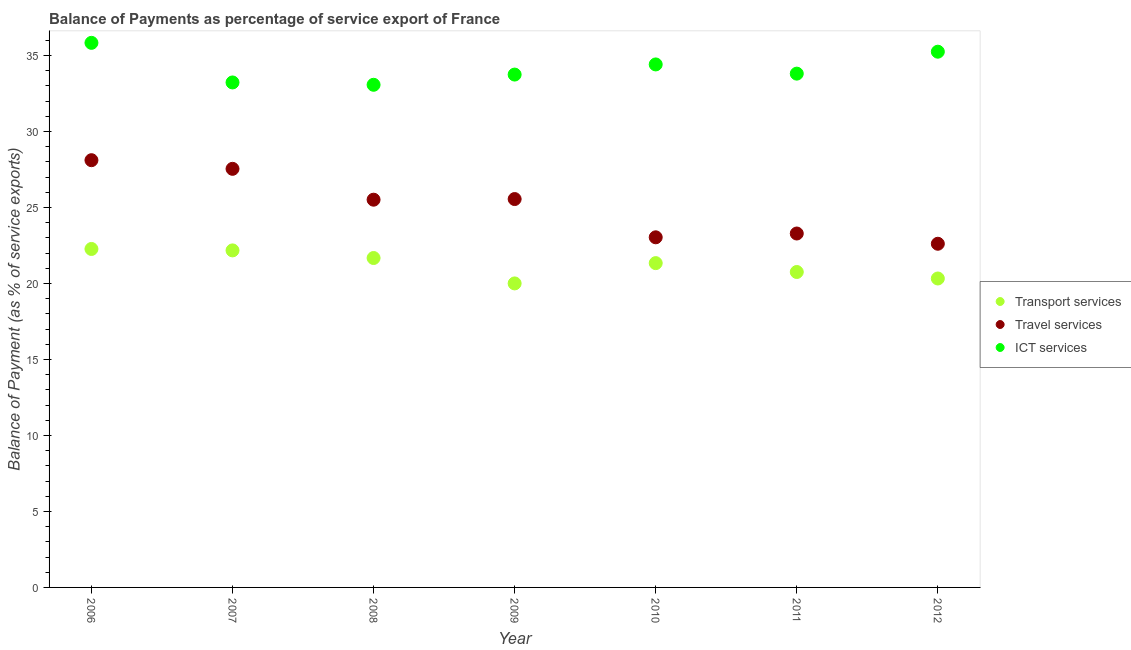How many different coloured dotlines are there?
Ensure brevity in your answer.  3. Is the number of dotlines equal to the number of legend labels?
Give a very brief answer. Yes. What is the balance of payment of transport services in 2012?
Your answer should be compact. 20.33. Across all years, what is the maximum balance of payment of transport services?
Make the answer very short. 22.27. Across all years, what is the minimum balance of payment of ict services?
Your answer should be very brief. 33.07. In which year was the balance of payment of travel services minimum?
Ensure brevity in your answer.  2012. What is the total balance of payment of travel services in the graph?
Keep it short and to the point. 175.66. What is the difference between the balance of payment of transport services in 2006 and that in 2007?
Your response must be concise. 0.09. What is the difference between the balance of payment of ict services in 2011 and the balance of payment of travel services in 2009?
Provide a succinct answer. 8.25. What is the average balance of payment of ict services per year?
Give a very brief answer. 34.19. In the year 2012, what is the difference between the balance of payment of travel services and balance of payment of transport services?
Your response must be concise. 2.29. In how many years, is the balance of payment of transport services greater than 1 %?
Ensure brevity in your answer.  7. What is the ratio of the balance of payment of ict services in 2008 to that in 2009?
Your response must be concise. 0.98. Is the difference between the balance of payment of travel services in 2009 and 2012 greater than the difference between the balance of payment of transport services in 2009 and 2012?
Provide a succinct answer. Yes. What is the difference between the highest and the second highest balance of payment of ict services?
Give a very brief answer. 0.58. What is the difference between the highest and the lowest balance of payment of travel services?
Your response must be concise. 5.5. In how many years, is the balance of payment of travel services greater than the average balance of payment of travel services taken over all years?
Your response must be concise. 4. Is the sum of the balance of payment of transport services in 2006 and 2009 greater than the maximum balance of payment of travel services across all years?
Provide a short and direct response. Yes. Is it the case that in every year, the sum of the balance of payment of transport services and balance of payment of travel services is greater than the balance of payment of ict services?
Offer a very short reply. Yes. Is the balance of payment of ict services strictly greater than the balance of payment of travel services over the years?
Your response must be concise. Yes. Is the balance of payment of travel services strictly less than the balance of payment of ict services over the years?
Ensure brevity in your answer.  Yes. How many years are there in the graph?
Offer a very short reply. 7. Are the values on the major ticks of Y-axis written in scientific E-notation?
Offer a terse response. No. Does the graph contain any zero values?
Provide a succinct answer. No. Where does the legend appear in the graph?
Offer a very short reply. Center right. What is the title of the graph?
Make the answer very short. Balance of Payments as percentage of service export of France. Does "Non-communicable diseases" appear as one of the legend labels in the graph?
Your answer should be compact. No. What is the label or title of the Y-axis?
Provide a short and direct response. Balance of Payment (as % of service exports). What is the Balance of Payment (as % of service exports) in Transport services in 2006?
Ensure brevity in your answer.  22.27. What is the Balance of Payment (as % of service exports) of Travel services in 2006?
Provide a succinct answer. 28.11. What is the Balance of Payment (as % of service exports) in ICT services in 2006?
Ensure brevity in your answer.  35.83. What is the Balance of Payment (as % of service exports) of Transport services in 2007?
Provide a succinct answer. 22.18. What is the Balance of Payment (as % of service exports) of Travel services in 2007?
Give a very brief answer. 27.54. What is the Balance of Payment (as % of service exports) of ICT services in 2007?
Ensure brevity in your answer.  33.23. What is the Balance of Payment (as % of service exports) in Transport services in 2008?
Provide a short and direct response. 21.67. What is the Balance of Payment (as % of service exports) of Travel services in 2008?
Offer a terse response. 25.51. What is the Balance of Payment (as % of service exports) in ICT services in 2008?
Your response must be concise. 33.07. What is the Balance of Payment (as % of service exports) in Transport services in 2009?
Give a very brief answer. 20. What is the Balance of Payment (as % of service exports) of Travel services in 2009?
Give a very brief answer. 25.55. What is the Balance of Payment (as % of service exports) in ICT services in 2009?
Your answer should be compact. 33.75. What is the Balance of Payment (as % of service exports) of Transport services in 2010?
Provide a short and direct response. 21.34. What is the Balance of Payment (as % of service exports) of Travel services in 2010?
Give a very brief answer. 23.04. What is the Balance of Payment (as % of service exports) of ICT services in 2010?
Provide a succinct answer. 34.41. What is the Balance of Payment (as % of service exports) in Transport services in 2011?
Provide a short and direct response. 20.75. What is the Balance of Payment (as % of service exports) of Travel services in 2011?
Your answer should be compact. 23.29. What is the Balance of Payment (as % of service exports) of ICT services in 2011?
Offer a very short reply. 33.81. What is the Balance of Payment (as % of service exports) of Transport services in 2012?
Offer a terse response. 20.33. What is the Balance of Payment (as % of service exports) of Travel services in 2012?
Your answer should be very brief. 22.61. What is the Balance of Payment (as % of service exports) in ICT services in 2012?
Ensure brevity in your answer.  35.25. Across all years, what is the maximum Balance of Payment (as % of service exports) in Transport services?
Your answer should be compact. 22.27. Across all years, what is the maximum Balance of Payment (as % of service exports) of Travel services?
Make the answer very short. 28.11. Across all years, what is the maximum Balance of Payment (as % of service exports) of ICT services?
Make the answer very short. 35.83. Across all years, what is the minimum Balance of Payment (as % of service exports) of Transport services?
Make the answer very short. 20. Across all years, what is the minimum Balance of Payment (as % of service exports) of Travel services?
Give a very brief answer. 22.61. Across all years, what is the minimum Balance of Payment (as % of service exports) of ICT services?
Provide a short and direct response. 33.07. What is the total Balance of Payment (as % of service exports) in Transport services in the graph?
Keep it short and to the point. 148.55. What is the total Balance of Payment (as % of service exports) of Travel services in the graph?
Offer a very short reply. 175.66. What is the total Balance of Payment (as % of service exports) in ICT services in the graph?
Offer a very short reply. 239.35. What is the difference between the Balance of Payment (as % of service exports) of Transport services in 2006 and that in 2007?
Offer a very short reply. 0.09. What is the difference between the Balance of Payment (as % of service exports) of Travel services in 2006 and that in 2007?
Your response must be concise. 0.57. What is the difference between the Balance of Payment (as % of service exports) in ICT services in 2006 and that in 2007?
Offer a very short reply. 2.61. What is the difference between the Balance of Payment (as % of service exports) of Transport services in 2006 and that in 2008?
Ensure brevity in your answer.  0.6. What is the difference between the Balance of Payment (as % of service exports) in Travel services in 2006 and that in 2008?
Keep it short and to the point. 2.6. What is the difference between the Balance of Payment (as % of service exports) of ICT services in 2006 and that in 2008?
Give a very brief answer. 2.76. What is the difference between the Balance of Payment (as % of service exports) in Transport services in 2006 and that in 2009?
Make the answer very short. 2.27. What is the difference between the Balance of Payment (as % of service exports) of Travel services in 2006 and that in 2009?
Your response must be concise. 2.56. What is the difference between the Balance of Payment (as % of service exports) of ICT services in 2006 and that in 2009?
Ensure brevity in your answer.  2.09. What is the difference between the Balance of Payment (as % of service exports) in Transport services in 2006 and that in 2010?
Your answer should be compact. 0.93. What is the difference between the Balance of Payment (as % of service exports) in Travel services in 2006 and that in 2010?
Your answer should be compact. 5.07. What is the difference between the Balance of Payment (as % of service exports) in ICT services in 2006 and that in 2010?
Offer a very short reply. 1.42. What is the difference between the Balance of Payment (as % of service exports) in Transport services in 2006 and that in 2011?
Offer a terse response. 1.52. What is the difference between the Balance of Payment (as % of service exports) in Travel services in 2006 and that in 2011?
Give a very brief answer. 4.82. What is the difference between the Balance of Payment (as % of service exports) in ICT services in 2006 and that in 2011?
Offer a terse response. 2.03. What is the difference between the Balance of Payment (as % of service exports) of Transport services in 2006 and that in 2012?
Give a very brief answer. 1.94. What is the difference between the Balance of Payment (as % of service exports) in Travel services in 2006 and that in 2012?
Your answer should be very brief. 5.5. What is the difference between the Balance of Payment (as % of service exports) of ICT services in 2006 and that in 2012?
Make the answer very short. 0.58. What is the difference between the Balance of Payment (as % of service exports) of Transport services in 2007 and that in 2008?
Provide a succinct answer. 0.5. What is the difference between the Balance of Payment (as % of service exports) in Travel services in 2007 and that in 2008?
Ensure brevity in your answer.  2.03. What is the difference between the Balance of Payment (as % of service exports) of ICT services in 2007 and that in 2008?
Offer a terse response. 0.15. What is the difference between the Balance of Payment (as % of service exports) of Transport services in 2007 and that in 2009?
Keep it short and to the point. 2.17. What is the difference between the Balance of Payment (as % of service exports) of Travel services in 2007 and that in 2009?
Your answer should be compact. 1.99. What is the difference between the Balance of Payment (as % of service exports) of ICT services in 2007 and that in 2009?
Provide a succinct answer. -0.52. What is the difference between the Balance of Payment (as % of service exports) of Transport services in 2007 and that in 2010?
Your answer should be compact. 0.84. What is the difference between the Balance of Payment (as % of service exports) in Travel services in 2007 and that in 2010?
Ensure brevity in your answer.  4.51. What is the difference between the Balance of Payment (as % of service exports) of ICT services in 2007 and that in 2010?
Your answer should be very brief. -1.19. What is the difference between the Balance of Payment (as % of service exports) of Transport services in 2007 and that in 2011?
Offer a terse response. 1.42. What is the difference between the Balance of Payment (as % of service exports) in Travel services in 2007 and that in 2011?
Offer a terse response. 4.26. What is the difference between the Balance of Payment (as % of service exports) in ICT services in 2007 and that in 2011?
Offer a very short reply. -0.58. What is the difference between the Balance of Payment (as % of service exports) of Transport services in 2007 and that in 2012?
Your answer should be compact. 1.85. What is the difference between the Balance of Payment (as % of service exports) of Travel services in 2007 and that in 2012?
Your answer should be very brief. 4.93. What is the difference between the Balance of Payment (as % of service exports) of ICT services in 2007 and that in 2012?
Provide a short and direct response. -2.02. What is the difference between the Balance of Payment (as % of service exports) in Transport services in 2008 and that in 2009?
Make the answer very short. 1.67. What is the difference between the Balance of Payment (as % of service exports) in Travel services in 2008 and that in 2009?
Make the answer very short. -0.04. What is the difference between the Balance of Payment (as % of service exports) of ICT services in 2008 and that in 2009?
Give a very brief answer. -0.67. What is the difference between the Balance of Payment (as % of service exports) of Transport services in 2008 and that in 2010?
Offer a very short reply. 0.34. What is the difference between the Balance of Payment (as % of service exports) in Travel services in 2008 and that in 2010?
Keep it short and to the point. 2.48. What is the difference between the Balance of Payment (as % of service exports) in ICT services in 2008 and that in 2010?
Provide a succinct answer. -1.34. What is the difference between the Balance of Payment (as % of service exports) of Travel services in 2008 and that in 2011?
Give a very brief answer. 2.23. What is the difference between the Balance of Payment (as % of service exports) of ICT services in 2008 and that in 2011?
Offer a terse response. -0.73. What is the difference between the Balance of Payment (as % of service exports) of Transport services in 2008 and that in 2012?
Offer a terse response. 1.35. What is the difference between the Balance of Payment (as % of service exports) in Travel services in 2008 and that in 2012?
Offer a terse response. 2.9. What is the difference between the Balance of Payment (as % of service exports) in ICT services in 2008 and that in 2012?
Provide a short and direct response. -2.18. What is the difference between the Balance of Payment (as % of service exports) of Transport services in 2009 and that in 2010?
Keep it short and to the point. -1.34. What is the difference between the Balance of Payment (as % of service exports) of Travel services in 2009 and that in 2010?
Your answer should be very brief. 2.52. What is the difference between the Balance of Payment (as % of service exports) of ICT services in 2009 and that in 2010?
Offer a terse response. -0.67. What is the difference between the Balance of Payment (as % of service exports) in Transport services in 2009 and that in 2011?
Give a very brief answer. -0.75. What is the difference between the Balance of Payment (as % of service exports) of Travel services in 2009 and that in 2011?
Your answer should be compact. 2.27. What is the difference between the Balance of Payment (as % of service exports) in ICT services in 2009 and that in 2011?
Ensure brevity in your answer.  -0.06. What is the difference between the Balance of Payment (as % of service exports) in Transport services in 2009 and that in 2012?
Ensure brevity in your answer.  -0.32. What is the difference between the Balance of Payment (as % of service exports) in Travel services in 2009 and that in 2012?
Make the answer very short. 2.94. What is the difference between the Balance of Payment (as % of service exports) in ICT services in 2009 and that in 2012?
Make the answer very short. -1.51. What is the difference between the Balance of Payment (as % of service exports) of Transport services in 2010 and that in 2011?
Offer a terse response. 0.58. What is the difference between the Balance of Payment (as % of service exports) in Travel services in 2010 and that in 2011?
Offer a very short reply. -0.25. What is the difference between the Balance of Payment (as % of service exports) in ICT services in 2010 and that in 2011?
Provide a succinct answer. 0.61. What is the difference between the Balance of Payment (as % of service exports) of Transport services in 2010 and that in 2012?
Give a very brief answer. 1.01. What is the difference between the Balance of Payment (as % of service exports) of Travel services in 2010 and that in 2012?
Your answer should be compact. 0.42. What is the difference between the Balance of Payment (as % of service exports) in ICT services in 2010 and that in 2012?
Give a very brief answer. -0.84. What is the difference between the Balance of Payment (as % of service exports) in Transport services in 2011 and that in 2012?
Offer a terse response. 0.43. What is the difference between the Balance of Payment (as % of service exports) in Travel services in 2011 and that in 2012?
Provide a succinct answer. 0.67. What is the difference between the Balance of Payment (as % of service exports) of ICT services in 2011 and that in 2012?
Provide a succinct answer. -1.44. What is the difference between the Balance of Payment (as % of service exports) in Transport services in 2006 and the Balance of Payment (as % of service exports) in Travel services in 2007?
Give a very brief answer. -5.27. What is the difference between the Balance of Payment (as % of service exports) in Transport services in 2006 and the Balance of Payment (as % of service exports) in ICT services in 2007?
Offer a terse response. -10.96. What is the difference between the Balance of Payment (as % of service exports) in Travel services in 2006 and the Balance of Payment (as % of service exports) in ICT services in 2007?
Provide a short and direct response. -5.12. What is the difference between the Balance of Payment (as % of service exports) in Transport services in 2006 and the Balance of Payment (as % of service exports) in Travel services in 2008?
Make the answer very short. -3.24. What is the difference between the Balance of Payment (as % of service exports) in Transport services in 2006 and the Balance of Payment (as % of service exports) in ICT services in 2008?
Offer a terse response. -10.8. What is the difference between the Balance of Payment (as % of service exports) of Travel services in 2006 and the Balance of Payment (as % of service exports) of ICT services in 2008?
Your answer should be very brief. -4.96. What is the difference between the Balance of Payment (as % of service exports) in Transport services in 2006 and the Balance of Payment (as % of service exports) in Travel services in 2009?
Provide a succinct answer. -3.28. What is the difference between the Balance of Payment (as % of service exports) of Transport services in 2006 and the Balance of Payment (as % of service exports) of ICT services in 2009?
Ensure brevity in your answer.  -11.47. What is the difference between the Balance of Payment (as % of service exports) in Travel services in 2006 and the Balance of Payment (as % of service exports) in ICT services in 2009?
Provide a short and direct response. -5.63. What is the difference between the Balance of Payment (as % of service exports) of Transport services in 2006 and the Balance of Payment (as % of service exports) of Travel services in 2010?
Provide a short and direct response. -0.77. What is the difference between the Balance of Payment (as % of service exports) in Transport services in 2006 and the Balance of Payment (as % of service exports) in ICT services in 2010?
Your answer should be very brief. -12.14. What is the difference between the Balance of Payment (as % of service exports) in Travel services in 2006 and the Balance of Payment (as % of service exports) in ICT services in 2010?
Give a very brief answer. -6.3. What is the difference between the Balance of Payment (as % of service exports) of Transport services in 2006 and the Balance of Payment (as % of service exports) of Travel services in 2011?
Your answer should be compact. -1.02. What is the difference between the Balance of Payment (as % of service exports) of Transport services in 2006 and the Balance of Payment (as % of service exports) of ICT services in 2011?
Provide a short and direct response. -11.54. What is the difference between the Balance of Payment (as % of service exports) in Travel services in 2006 and the Balance of Payment (as % of service exports) in ICT services in 2011?
Your answer should be very brief. -5.7. What is the difference between the Balance of Payment (as % of service exports) in Transport services in 2006 and the Balance of Payment (as % of service exports) in Travel services in 2012?
Ensure brevity in your answer.  -0.34. What is the difference between the Balance of Payment (as % of service exports) in Transport services in 2006 and the Balance of Payment (as % of service exports) in ICT services in 2012?
Ensure brevity in your answer.  -12.98. What is the difference between the Balance of Payment (as % of service exports) of Travel services in 2006 and the Balance of Payment (as % of service exports) of ICT services in 2012?
Make the answer very short. -7.14. What is the difference between the Balance of Payment (as % of service exports) in Transport services in 2007 and the Balance of Payment (as % of service exports) in Travel services in 2008?
Provide a short and direct response. -3.34. What is the difference between the Balance of Payment (as % of service exports) of Transport services in 2007 and the Balance of Payment (as % of service exports) of ICT services in 2008?
Keep it short and to the point. -10.9. What is the difference between the Balance of Payment (as % of service exports) of Travel services in 2007 and the Balance of Payment (as % of service exports) of ICT services in 2008?
Your response must be concise. -5.53. What is the difference between the Balance of Payment (as % of service exports) of Transport services in 2007 and the Balance of Payment (as % of service exports) of Travel services in 2009?
Your response must be concise. -3.38. What is the difference between the Balance of Payment (as % of service exports) in Transport services in 2007 and the Balance of Payment (as % of service exports) in ICT services in 2009?
Keep it short and to the point. -11.57. What is the difference between the Balance of Payment (as % of service exports) of Travel services in 2007 and the Balance of Payment (as % of service exports) of ICT services in 2009?
Provide a short and direct response. -6.2. What is the difference between the Balance of Payment (as % of service exports) of Transport services in 2007 and the Balance of Payment (as % of service exports) of Travel services in 2010?
Provide a succinct answer. -0.86. What is the difference between the Balance of Payment (as % of service exports) in Transport services in 2007 and the Balance of Payment (as % of service exports) in ICT services in 2010?
Provide a succinct answer. -12.24. What is the difference between the Balance of Payment (as % of service exports) of Travel services in 2007 and the Balance of Payment (as % of service exports) of ICT services in 2010?
Ensure brevity in your answer.  -6.87. What is the difference between the Balance of Payment (as % of service exports) in Transport services in 2007 and the Balance of Payment (as % of service exports) in Travel services in 2011?
Offer a very short reply. -1.11. What is the difference between the Balance of Payment (as % of service exports) in Transport services in 2007 and the Balance of Payment (as % of service exports) in ICT services in 2011?
Provide a succinct answer. -11.63. What is the difference between the Balance of Payment (as % of service exports) in Travel services in 2007 and the Balance of Payment (as % of service exports) in ICT services in 2011?
Make the answer very short. -6.26. What is the difference between the Balance of Payment (as % of service exports) in Transport services in 2007 and the Balance of Payment (as % of service exports) in Travel services in 2012?
Ensure brevity in your answer.  -0.44. What is the difference between the Balance of Payment (as % of service exports) in Transport services in 2007 and the Balance of Payment (as % of service exports) in ICT services in 2012?
Ensure brevity in your answer.  -13.07. What is the difference between the Balance of Payment (as % of service exports) in Travel services in 2007 and the Balance of Payment (as % of service exports) in ICT services in 2012?
Offer a terse response. -7.71. What is the difference between the Balance of Payment (as % of service exports) in Transport services in 2008 and the Balance of Payment (as % of service exports) in Travel services in 2009?
Keep it short and to the point. -3.88. What is the difference between the Balance of Payment (as % of service exports) in Transport services in 2008 and the Balance of Payment (as % of service exports) in ICT services in 2009?
Offer a very short reply. -12.07. What is the difference between the Balance of Payment (as % of service exports) of Travel services in 2008 and the Balance of Payment (as % of service exports) of ICT services in 2009?
Keep it short and to the point. -8.23. What is the difference between the Balance of Payment (as % of service exports) of Transport services in 2008 and the Balance of Payment (as % of service exports) of Travel services in 2010?
Give a very brief answer. -1.36. What is the difference between the Balance of Payment (as % of service exports) in Transport services in 2008 and the Balance of Payment (as % of service exports) in ICT services in 2010?
Ensure brevity in your answer.  -12.74. What is the difference between the Balance of Payment (as % of service exports) in Travel services in 2008 and the Balance of Payment (as % of service exports) in ICT services in 2010?
Keep it short and to the point. -8.9. What is the difference between the Balance of Payment (as % of service exports) of Transport services in 2008 and the Balance of Payment (as % of service exports) of Travel services in 2011?
Provide a succinct answer. -1.61. What is the difference between the Balance of Payment (as % of service exports) in Transport services in 2008 and the Balance of Payment (as % of service exports) in ICT services in 2011?
Your answer should be compact. -12.13. What is the difference between the Balance of Payment (as % of service exports) of Travel services in 2008 and the Balance of Payment (as % of service exports) of ICT services in 2011?
Keep it short and to the point. -8.29. What is the difference between the Balance of Payment (as % of service exports) of Transport services in 2008 and the Balance of Payment (as % of service exports) of Travel services in 2012?
Your answer should be very brief. -0.94. What is the difference between the Balance of Payment (as % of service exports) in Transport services in 2008 and the Balance of Payment (as % of service exports) in ICT services in 2012?
Provide a succinct answer. -13.58. What is the difference between the Balance of Payment (as % of service exports) of Travel services in 2008 and the Balance of Payment (as % of service exports) of ICT services in 2012?
Make the answer very short. -9.74. What is the difference between the Balance of Payment (as % of service exports) in Transport services in 2009 and the Balance of Payment (as % of service exports) in Travel services in 2010?
Offer a terse response. -3.03. What is the difference between the Balance of Payment (as % of service exports) of Transport services in 2009 and the Balance of Payment (as % of service exports) of ICT services in 2010?
Your answer should be very brief. -14.41. What is the difference between the Balance of Payment (as % of service exports) in Travel services in 2009 and the Balance of Payment (as % of service exports) in ICT services in 2010?
Ensure brevity in your answer.  -8.86. What is the difference between the Balance of Payment (as % of service exports) in Transport services in 2009 and the Balance of Payment (as % of service exports) in Travel services in 2011?
Provide a short and direct response. -3.28. What is the difference between the Balance of Payment (as % of service exports) of Transport services in 2009 and the Balance of Payment (as % of service exports) of ICT services in 2011?
Provide a short and direct response. -13.8. What is the difference between the Balance of Payment (as % of service exports) in Travel services in 2009 and the Balance of Payment (as % of service exports) in ICT services in 2011?
Your answer should be compact. -8.25. What is the difference between the Balance of Payment (as % of service exports) in Transport services in 2009 and the Balance of Payment (as % of service exports) in Travel services in 2012?
Your answer should be compact. -2.61. What is the difference between the Balance of Payment (as % of service exports) in Transport services in 2009 and the Balance of Payment (as % of service exports) in ICT services in 2012?
Provide a succinct answer. -15.25. What is the difference between the Balance of Payment (as % of service exports) of Travel services in 2009 and the Balance of Payment (as % of service exports) of ICT services in 2012?
Make the answer very short. -9.7. What is the difference between the Balance of Payment (as % of service exports) in Transport services in 2010 and the Balance of Payment (as % of service exports) in Travel services in 2011?
Ensure brevity in your answer.  -1.95. What is the difference between the Balance of Payment (as % of service exports) of Transport services in 2010 and the Balance of Payment (as % of service exports) of ICT services in 2011?
Keep it short and to the point. -12.47. What is the difference between the Balance of Payment (as % of service exports) in Travel services in 2010 and the Balance of Payment (as % of service exports) in ICT services in 2011?
Offer a very short reply. -10.77. What is the difference between the Balance of Payment (as % of service exports) of Transport services in 2010 and the Balance of Payment (as % of service exports) of Travel services in 2012?
Your answer should be compact. -1.27. What is the difference between the Balance of Payment (as % of service exports) of Transport services in 2010 and the Balance of Payment (as % of service exports) of ICT services in 2012?
Your response must be concise. -13.91. What is the difference between the Balance of Payment (as % of service exports) in Travel services in 2010 and the Balance of Payment (as % of service exports) in ICT services in 2012?
Give a very brief answer. -12.21. What is the difference between the Balance of Payment (as % of service exports) of Transport services in 2011 and the Balance of Payment (as % of service exports) of Travel services in 2012?
Provide a succinct answer. -1.86. What is the difference between the Balance of Payment (as % of service exports) in Transport services in 2011 and the Balance of Payment (as % of service exports) in ICT services in 2012?
Offer a terse response. -14.5. What is the difference between the Balance of Payment (as % of service exports) of Travel services in 2011 and the Balance of Payment (as % of service exports) of ICT services in 2012?
Give a very brief answer. -11.96. What is the average Balance of Payment (as % of service exports) of Transport services per year?
Provide a succinct answer. 21.22. What is the average Balance of Payment (as % of service exports) in Travel services per year?
Your answer should be very brief. 25.09. What is the average Balance of Payment (as % of service exports) in ICT services per year?
Your response must be concise. 34.19. In the year 2006, what is the difference between the Balance of Payment (as % of service exports) of Transport services and Balance of Payment (as % of service exports) of Travel services?
Your answer should be very brief. -5.84. In the year 2006, what is the difference between the Balance of Payment (as % of service exports) of Transport services and Balance of Payment (as % of service exports) of ICT services?
Ensure brevity in your answer.  -13.56. In the year 2006, what is the difference between the Balance of Payment (as % of service exports) in Travel services and Balance of Payment (as % of service exports) in ICT services?
Your answer should be compact. -7.72. In the year 2007, what is the difference between the Balance of Payment (as % of service exports) in Transport services and Balance of Payment (as % of service exports) in Travel services?
Your response must be concise. -5.37. In the year 2007, what is the difference between the Balance of Payment (as % of service exports) in Transport services and Balance of Payment (as % of service exports) in ICT services?
Your answer should be very brief. -11.05. In the year 2007, what is the difference between the Balance of Payment (as % of service exports) in Travel services and Balance of Payment (as % of service exports) in ICT services?
Offer a terse response. -5.68. In the year 2008, what is the difference between the Balance of Payment (as % of service exports) in Transport services and Balance of Payment (as % of service exports) in Travel services?
Your response must be concise. -3.84. In the year 2008, what is the difference between the Balance of Payment (as % of service exports) in Transport services and Balance of Payment (as % of service exports) in ICT services?
Your response must be concise. -11.4. In the year 2008, what is the difference between the Balance of Payment (as % of service exports) in Travel services and Balance of Payment (as % of service exports) in ICT services?
Keep it short and to the point. -7.56. In the year 2009, what is the difference between the Balance of Payment (as % of service exports) of Transport services and Balance of Payment (as % of service exports) of Travel services?
Your answer should be very brief. -5.55. In the year 2009, what is the difference between the Balance of Payment (as % of service exports) of Transport services and Balance of Payment (as % of service exports) of ICT services?
Keep it short and to the point. -13.74. In the year 2009, what is the difference between the Balance of Payment (as % of service exports) of Travel services and Balance of Payment (as % of service exports) of ICT services?
Offer a terse response. -8.19. In the year 2010, what is the difference between the Balance of Payment (as % of service exports) in Transport services and Balance of Payment (as % of service exports) in Travel services?
Keep it short and to the point. -1.7. In the year 2010, what is the difference between the Balance of Payment (as % of service exports) in Transport services and Balance of Payment (as % of service exports) in ICT services?
Your answer should be compact. -13.07. In the year 2010, what is the difference between the Balance of Payment (as % of service exports) of Travel services and Balance of Payment (as % of service exports) of ICT services?
Your response must be concise. -11.38. In the year 2011, what is the difference between the Balance of Payment (as % of service exports) in Transport services and Balance of Payment (as % of service exports) in Travel services?
Provide a short and direct response. -2.53. In the year 2011, what is the difference between the Balance of Payment (as % of service exports) of Transport services and Balance of Payment (as % of service exports) of ICT services?
Provide a succinct answer. -13.05. In the year 2011, what is the difference between the Balance of Payment (as % of service exports) in Travel services and Balance of Payment (as % of service exports) in ICT services?
Make the answer very short. -10.52. In the year 2012, what is the difference between the Balance of Payment (as % of service exports) of Transport services and Balance of Payment (as % of service exports) of Travel services?
Your answer should be very brief. -2.29. In the year 2012, what is the difference between the Balance of Payment (as % of service exports) in Transport services and Balance of Payment (as % of service exports) in ICT services?
Your answer should be very brief. -14.92. In the year 2012, what is the difference between the Balance of Payment (as % of service exports) in Travel services and Balance of Payment (as % of service exports) in ICT services?
Provide a short and direct response. -12.64. What is the ratio of the Balance of Payment (as % of service exports) in Travel services in 2006 to that in 2007?
Provide a short and direct response. 1.02. What is the ratio of the Balance of Payment (as % of service exports) of ICT services in 2006 to that in 2007?
Provide a short and direct response. 1.08. What is the ratio of the Balance of Payment (as % of service exports) of Transport services in 2006 to that in 2008?
Your answer should be compact. 1.03. What is the ratio of the Balance of Payment (as % of service exports) of Travel services in 2006 to that in 2008?
Keep it short and to the point. 1.1. What is the ratio of the Balance of Payment (as % of service exports) of ICT services in 2006 to that in 2008?
Keep it short and to the point. 1.08. What is the ratio of the Balance of Payment (as % of service exports) of Transport services in 2006 to that in 2009?
Keep it short and to the point. 1.11. What is the ratio of the Balance of Payment (as % of service exports) in ICT services in 2006 to that in 2009?
Give a very brief answer. 1.06. What is the ratio of the Balance of Payment (as % of service exports) in Transport services in 2006 to that in 2010?
Your answer should be compact. 1.04. What is the ratio of the Balance of Payment (as % of service exports) of Travel services in 2006 to that in 2010?
Keep it short and to the point. 1.22. What is the ratio of the Balance of Payment (as % of service exports) of ICT services in 2006 to that in 2010?
Provide a succinct answer. 1.04. What is the ratio of the Balance of Payment (as % of service exports) in Transport services in 2006 to that in 2011?
Ensure brevity in your answer.  1.07. What is the ratio of the Balance of Payment (as % of service exports) of Travel services in 2006 to that in 2011?
Provide a short and direct response. 1.21. What is the ratio of the Balance of Payment (as % of service exports) of ICT services in 2006 to that in 2011?
Your response must be concise. 1.06. What is the ratio of the Balance of Payment (as % of service exports) of Transport services in 2006 to that in 2012?
Offer a very short reply. 1.1. What is the ratio of the Balance of Payment (as % of service exports) of Travel services in 2006 to that in 2012?
Your answer should be compact. 1.24. What is the ratio of the Balance of Payment (as % of service exports) of ICT services in 2006 to that in 2012?
Provide a short and direct response. 1.02. What is the ratio of the Balance of Payment (as % of service exports) of Transport services in 2007 to that in 2008?
Your answer should be very brief. 1.02. What is the ratio of the Balance of Payment (as % of service exports) of Travel services in 2007 to that in 2008?
Make the answer very short. 1.08. What is the ratio of the Balance of Payment (as % of service exports) in ICT services in 2007 to that in 2008?
Your answer should be very brief. 1. What is the ratio of the Balance of Payment (as % of service exports) of Transport services in 2007 to that in 2009?
Make the answer very short. 1.11. What is the ratio of the Balance of Payment (as % of service exports) of Travel services in 2007 to that in 2009?
Offer a very short reply. 1.08. What is the ratio of the Balance of Payment (as % of service exports) in ICT services in 2007 to that in 2009?
Your answer should be compact. 0.98. What is the ratio of the Balance of Payment (as % of service exports) of Transport services in 2007 to that in 2010?
Your answer should be compact. 1.04. What is the ratio of the Balance of Payment (as % of service exports) in Travel services in 2007 to that in 2010?
Make the answer very short. 1.2. What is the ratio of the Balance of Payment (as % of service exports) of ICT services in 2007 to that in 2010?
Offer a terse response. 0.97. What is the ratio of the Balance of Payment (as % of service exports) of Transport services in 2007 to that in 2011?
Provide a succinct answer. 1.07. What is the ratio of the Balance of Payment (as % of service exports) in Travel services in 2007 to that in 2011?
Your answer should be compact. 1.18. What is the ratio of the Balance of Payment (as % of service exports) of ICT services in 2007 to that in 2011?
Your answer should be compact. 0.98. What is the ratio of the Balance of Payment (as % of service exports) of Transport services in 2007 to that in 2012?
Provide a succinct answer. 1.09. What is the ratio of the Balance of Payment (as % of service exports) of Travel services in 2007 to that in 2012?
Make the answer very short. 1.22. What is the ratio of the Balance of Payment (as % of service exports) of ICT services in 2007 to that in 2012?
Your answer should be very brief. 0.94. What is the ratio of the Balance of Payment (as % of service exports) of Transport services in 2008 to that in 2009?
Your response must be concise. 1.08. What is the ratio of the Balance of Payment (as % of service exports) in Travel services in 2008 to that in 2009?
Make the answer very short. 1. What is the ratio of the Balance of Payment (as % of service exports) in ICT services in 2008 to that in 2009?
Make the answer very short. 0.98. What is the ratio of the Balance of Payment (as % of service exports) in Transport services in 2008 to that in 2010?
Offer a very short reply. 1.02. What is the ratio of the Balance of Payment (as % of service exports) of Travel services in 2008 to that in 2010?
Keep it short and to the point. 1.11. What is the ratio of the Balance of Payment (as % of service exports) in ICT services in 2008 to that in 2010?
Provide a succinct answer. 0.96. What is the ratio of the Balance of Payment (as % of service exports) of Transport services in 2008 to that in 2011?
Your response must be concise. 1.04. What is the ratio of the Balance of Payment (as % of service exports) in Travel services in 2008 to that in 2011?
Your answer should be very brief. 1.1. What is the ratio of the Balance of Payment (as % of service exports) of ICT services in 2008 to that in 2011?
Provide a succinct answer. 0.98. What is the ratio of the Balance of Payment (as % of service exports) of Transport services in 2008 to that in 2012?
Give a very brief answer. 1.07. What is the ratio of the Balance of Payment (as % of service exports) in Travel services in 2008 to that in 2012?
Offer a terse response. 1.13. What is the ratio of the Balance of Payment (as % of service exports) of ICT services in 2008 to that in 2012?
Your answer should be very brief. 0.94. What is the ratio of the Balance of Payment (as % of service exports) of Transport services in 2009 to that in 2010?
Keep it short and to the point. 0.94. What is the ratio of the Balance of Payment (as % of service exports) in Travel services in 2009 to that in 2010?
Your answer should be very brief. 1.11. What is the ratio of the Balance of Payment (as % of service exports) in ICT services in 2009 to that in 2010?
Offer a terse response. 0.98. What is the ratio of the Balance of Payment (as % of service exports) in Transport services in 2009 to that in 2011?
Make the answer very short. 0.96. What is the ratio of the Balance of Payment (as % of service exports) of Travel services in 2009 to that in 2011?
Your response must be concise. 1.1. What is the ratio of the Balance of Payment (as % of service exports) in Transport services in 2009 to that in 2012?
Keep it short and to the point. 0.98. What is the ratio of the Balance of Payment (as % of service exports) of Travel services in 2009 to that in 2012?
Make the answer very short. 1.13. What is the ratio of the Balance of Payment (as % of service exports) of ICT services in 2009 to that in 2012?
Provide a succinct answer. 0.96. What is the ratio of the Balance of Payment (as % of service exports) in Transport services in 2010 to that in 2011?
Your answer should be very brief. 1.03. What is the ratio of the Balance of Payment (as % of service exports) in Travel services in 2010 to that in 2011?
Keep it short and to the point. 0.99. What is the ratio of the Balance of Payment (as % of service exports) of ICT services in 2010 to that in 2011?
Your response must be concise. 1.02. What is the ratio of the Balance of Payment (as % of service exports) in Transport services in 2010 to that in 2012?
Make the answer very short. 1.05. What is the ratio of the Balance of Payment (as % of service exports) of Travel services in 2010 to that in 2012?
Offer a terse response. 1.02. What is the ratio of the Balance of Payment (as % of service exports) in ICT services in 2010 to that in 2012?
Your answer should be very brief. 0.98. What is the ratio of the Balance of Payment (as % of service exports) of Travel services in 2011 to that in 2012?
Your answer should be compact. 1.03. What is the difference between the highest and the second highest Balance of Payment (as % of service exports) of Transport services?
Offer a terse response. 0.09. What is the difference between the highest and the second highest Balance of Payment (as % of service exports) in Travel services?
Give a very brief answer. 0.57. What is the difference between the highest and the second highest Balance of Payment (as % of service exports) in ICT services?
Make the answer very short. 0.58. What is the difference between the highest and the lowest Balance of Payment (as % of service exports) of Transport services?
Offer a terse response. 2.27. What is the difference between the highest and the lowest Balance of Payment (as % of service exports) of Travel services?
Give a very brief answer. 5.5. What is the difference between the highest and the lowest Balance of Payment (as % of service exports) in ICT services?
Your response must be concise. 2.76. 